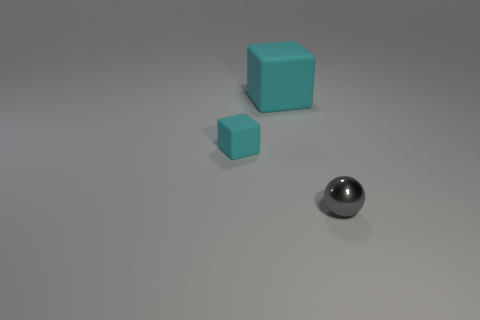Are there fewer small objects to the left of the small cyan object than small matte blocks that are in front of the big cube?
Provide a succinct answer. Yes. There is a rubber thing behind the small cyan cube; what size is it?
Ensure brevity in your answer.  Large. How many things are both in front of the large cyan matte block and behind the ball?
Your response must be concise. 1. How many cyan objects are either small spheres or small rubber cubes?
Your answer should be very brief. 1. How many metallic things are either tiny gray cylinders or small cyan cubes?
Provide a short and direct response. 0. Is there a tiny gray sphere?
Your answer should be compact. Yes. Is the shape of the large cyan matte object the same as the tiny gray object?
Your answer should be compact. No. There is a cyan matte object that is right of the small object behind the sphere; what number of small gray things are to the left of it?
Offer a terse response. 0. There is a thing that is both in front of the large matte cube and behind the ball; what is it made of?
Your answer should be very brief. Rubber. What color is the object that is both in front of the large matte block and right of the tiny cyan cube?
Provide a succinct answer. Gray. 